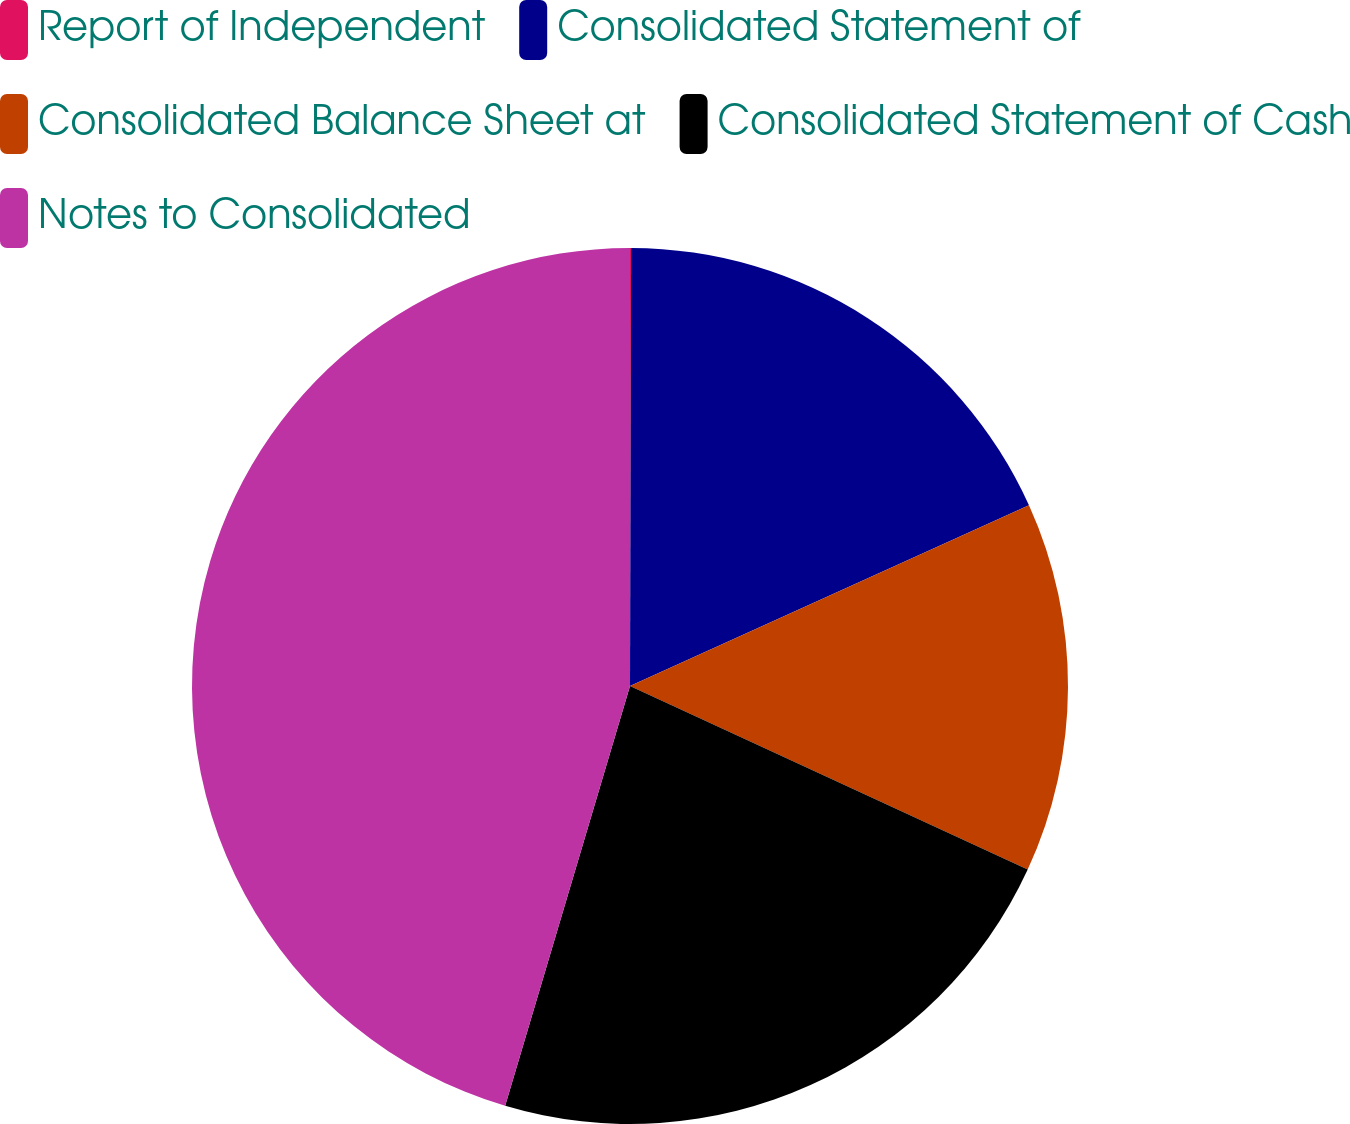<chart> <loc_0><loc_0><loc_500><loc_500><pie_chart><fcel>Report of Independent<fcel>Consolidated Statement of<fcel>Consolidated Balance Sheet at<fcel>Consolidated Statement of Cash<fcel>Notes to Consolidated<nl><fcel>0.04%<fcel>18.19%<fcel>13.65%<fcel>22.72%<fcel>45.4%<nl></chart> 